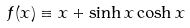Convert formula to latex. <formula><loc_0><loc_0><loc_500><loc_500>f ( x ) \equiv x + \sinh x \cosh x</formula> 